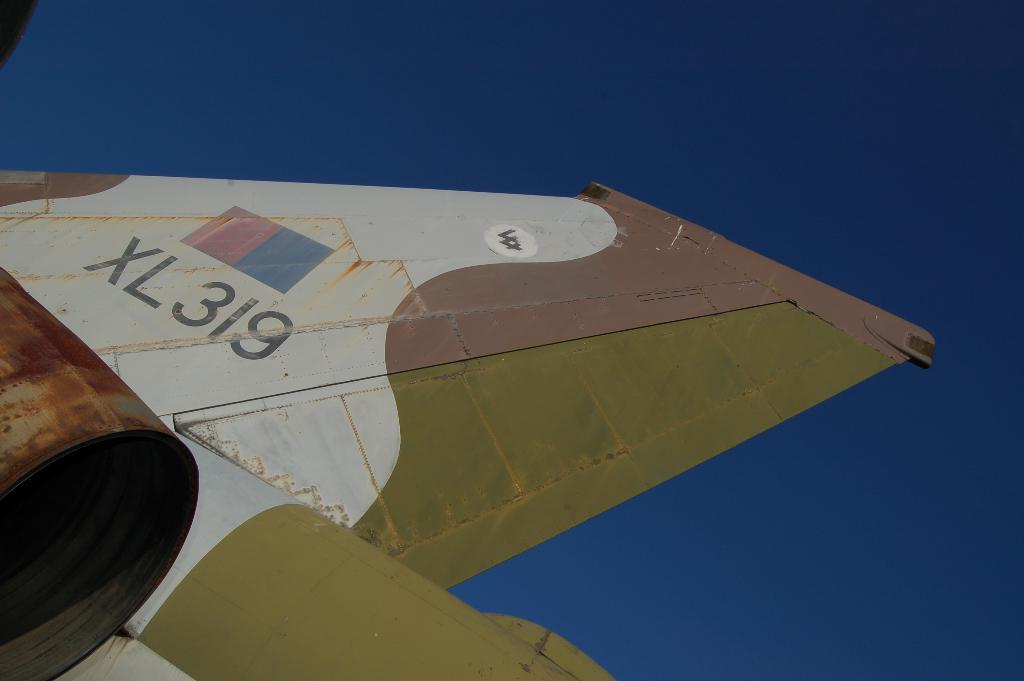Provide a one-sentence caption for the provided image. The airplane wing has letters and numbers XL319. 